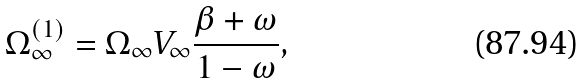<formula> <loc_0><loc_0><loc_500><loc_500>\Omega _ { \infty } ^ { ( 1 ) } = \Omega _ { \infty } V _ { \infty } \frac { \beta + \omega } { 1 - \omega } ,</formula> 